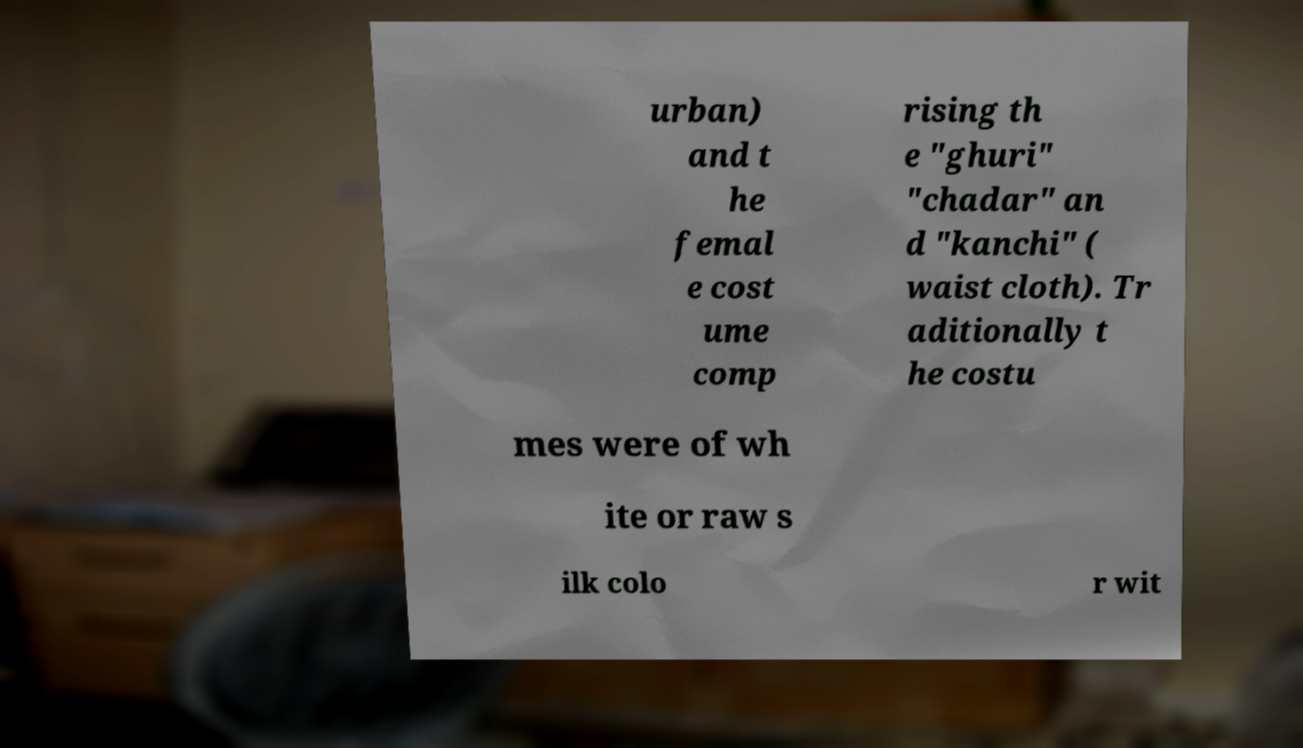Please identify and transcribe the text found in this image. urban) and t he femal e cost ume comp rising th e "ghuri" "chadar" an d "kanchi" ( waist cloth). Tr aditionally t he costu mes were of wh ite or raw s ilk colo r wit 